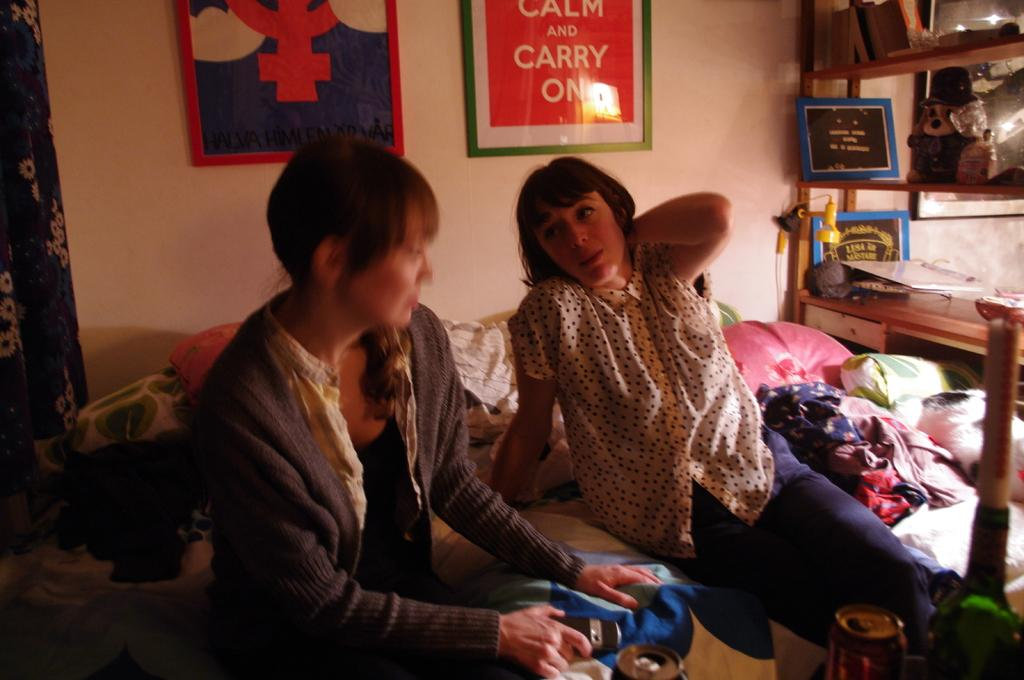How many people are in the image? There are two women in the image. What are the women doing in the image? The women are sitting on a bed and speaking to each other. What is on the bed besides the women? The bed has many clothes on it. What can be seen on the right side of the image? There is a table on the right side of the image. What is visible in the background of the image? There is a wall in the background of the image. What type of hen can be seen in the image? There is no hen present in the image. What is the father of the women doing in the image? There is no father present in the image. 